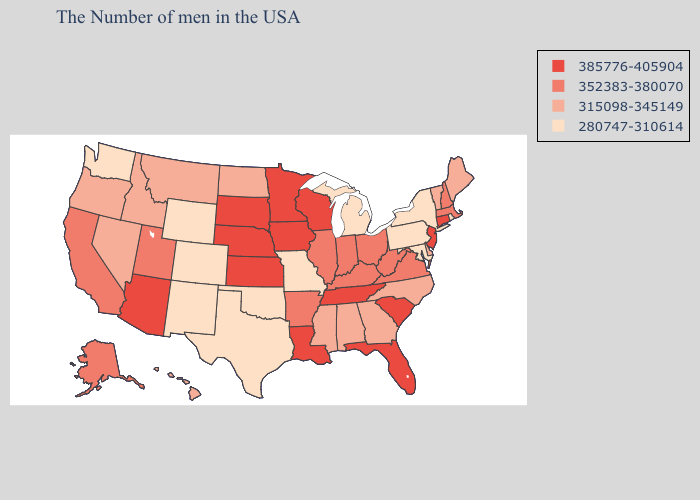Does the first symbol in the legend represent the smallest category?
Write a very short answer. No. What is the highest value in the South ?
Give a very brief answer. 385776-405904. Which states hav the highest value in the Northeast?
Short answer required. Connecticut, New Jersey. Does the map have missing data?
Give a very brief answer. No. Name the states that have a value in the range 352383-380070?
Write a very short answer. Massachusetts, New Hampshire, Virginia, West Virginia, Ohio, Kentucky, Indiana, Illinois, Arkansas, Utah, California, Alaska. Is the legend a continuous bar?
Answer briefly. No. Name the states that have a value in the range 352383-380070?
Short answer required. Massachusetts, New Hampshire, Virginia, West Virginia, Ohio, Kentucky, Indiana, Illinois, Arkansas, Utah, California, Alaska. Name the states that have a value in the range 315098-345149?
Give a very brief answer. Maine, Vermont, Delaware, North Carolina, Georgia, Alabama, Mississippi, North Dakota, Montana, Idaho, Nevada, Oregon, Hawaii. Does Arkansas have the highest value in the USA?
Write a very short answer. No. What is the value of Montana?
Concise answer only. 315098-345149. Which states have the lowest value in the MidWest?
Quick response, please. Michigan, Missouri. Among the states that border Maine , which have the lowest value?
Answer briefly. New Hampshire. Does Arizona have the lowest value in the West?
Answer briefly. No. Which states have the lowest value in the USA?
Be succinct. Rhode Island, New York, Maryland, Pennsylvania, Michigan, Missouri, Oklahoma, Texas, Wyoming, Colorado, New Mexico, Washington. Does South Dakota have the highest value in the USA?
Write a very short answer. Yes. 